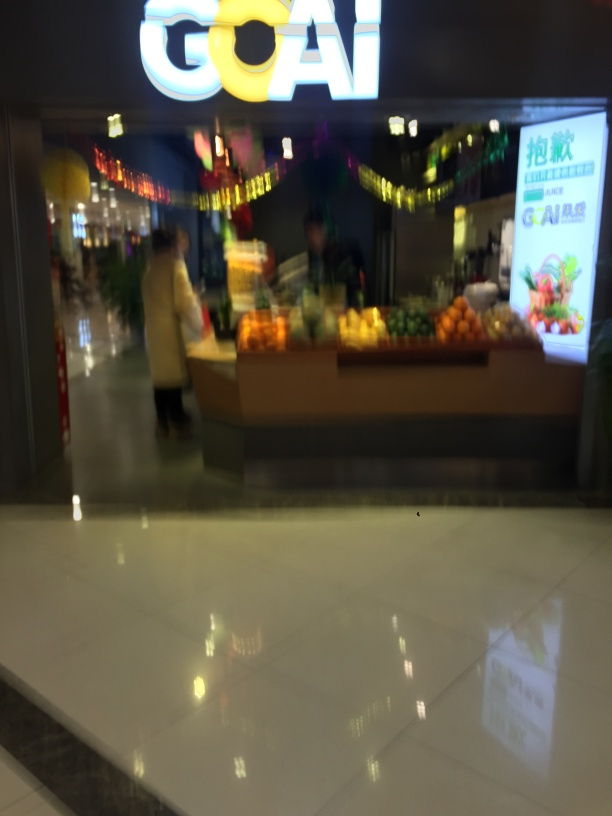Are there any distinctive decorations or designs that can hint at the time of year or the type of market? The decorations hanging from the ceiling appear to be festive, possibly suggesting that the photo was taken around a holiday period or during a special event. The inclusion of such decorations usually indicates an attempt to attract customers with a festive atmosphere. 